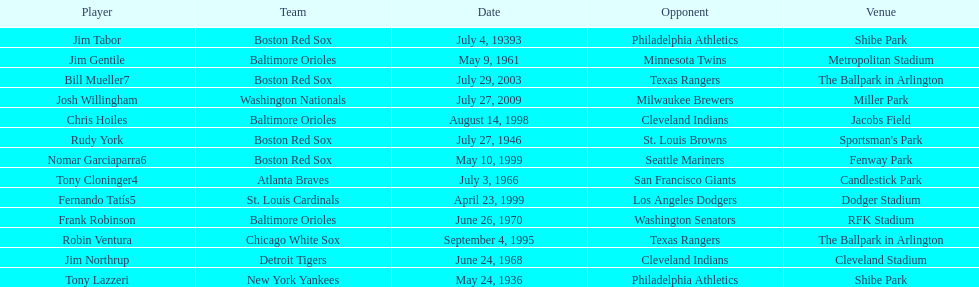What is the name of the player for the new york yankees in 1936? Tony Lazzeri. 